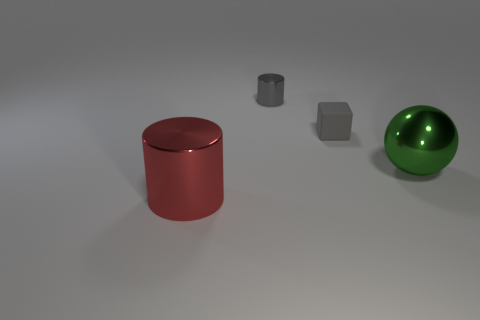Add 3 tiny blue rubber balls. How many objects exist? 7 Add 1 big shiny spheres. How many big shiny spheres are left? 2 Add 4 large red cylinders. How many large red cylinders exist? 5 Subtract 0 yellow blocks. How many objects are left? 4 Subtract all small red shiny objects. Subtract all matte cubes. How many objects are left? 3 